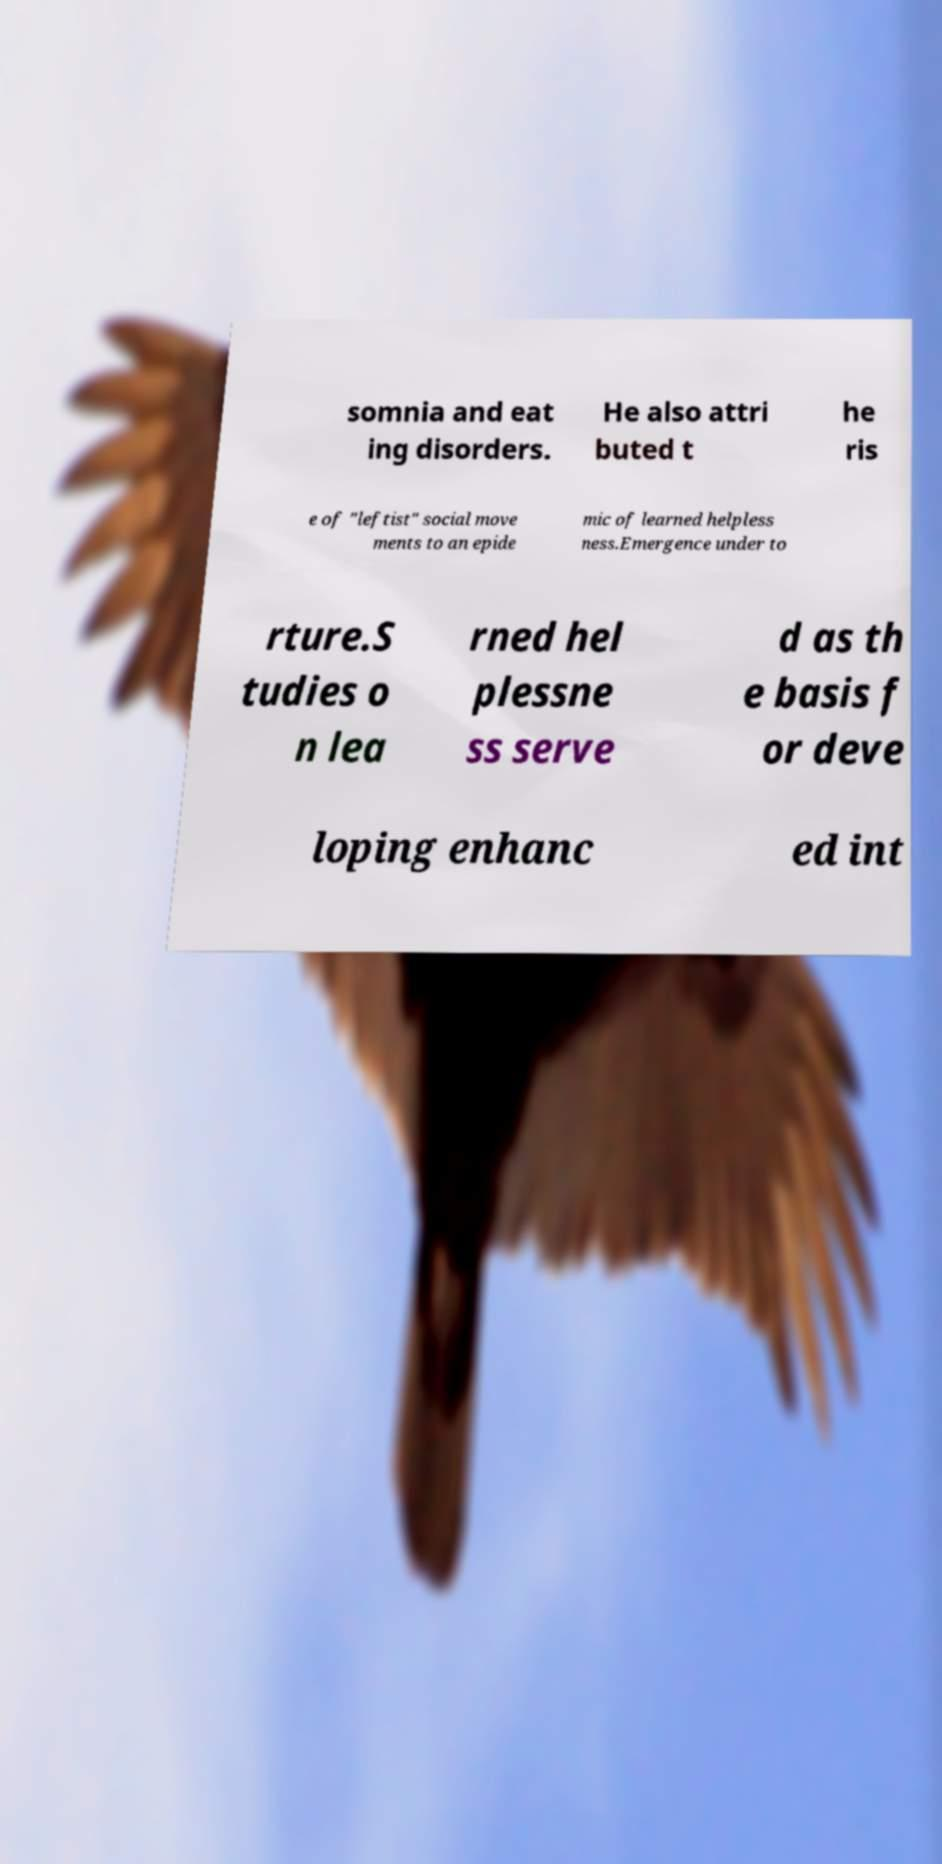Please identify and transcribe the text found in this image. somnia and eat ing disorders. He also attri buted t he ris e of "leftist" social move ments to an epide mic of learned helpless ness.Emergence under to rture.S tudies o n lea rned hel plessne ss serve d as th e basis f or deve loping enhanc ed int 